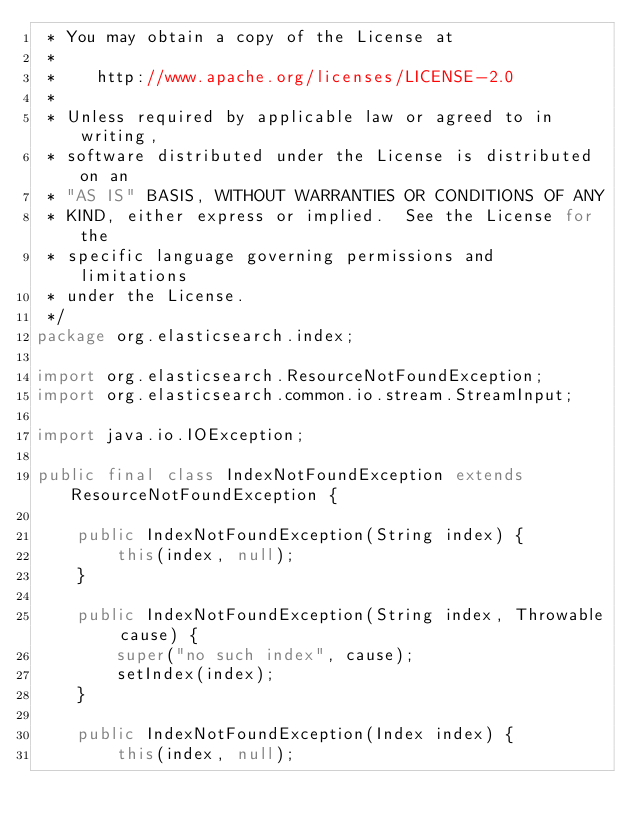Convert code to text. <code><loc_0><loc_0><loc_500><loc_500><_Java_> * You may obtain a copy of the License at
 *
 *    http://www.apache.org/licenses/LICENSE-2.0
 *
 * Unless required by applicable law or agreed to in writing,
 * software distributed under the License is distributed on an
 * "AS IS" BASIS, WITHOUT WARRANTIES OR CONDITIONS OF ANY
 * KIND, either express or implied.  See the License for the
 * specific language governing permissions and limitations
 * under the License.
 */
package org.elasticsearch.index;

import org.elasticsearch.ResourceNotFoundException;
import org.elasticsearch.common.io.stream.StreamInput;

import java.io.IOException;

public final class IndexNotFoundException extends ResourceNotFoundException {

    public IndexNotFoundException(String index) {
        this(index, null);
    }

    public IndexNotFoundException(String index, Throwable cause) {
        super("no such index", cause);
        setIndex(index);
    }

    public IndexNotFoundException(Index index) {
        this(index, null);</code> 